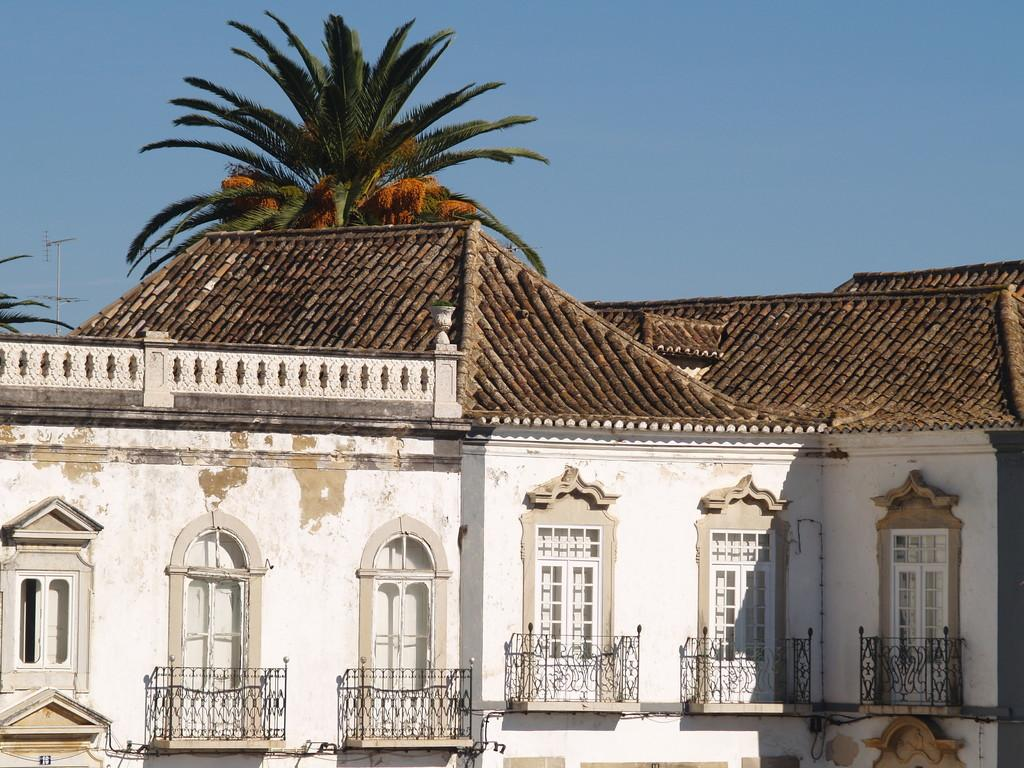What type of structure is present in the image? There is a building in the image. What architectural feature can be seen on the building? There are iron grilles in the image. What type of vegetation is present in the image? There are trees in the image. What can be seen in the background of the image? The sky is visible in the background of the image. How many buttons can be seen on the trees in the image? There are no buttons present on the trees in the image. What color are the eyes of the building in the image? Buildings do not have eyes, so this question cannot be answered. 